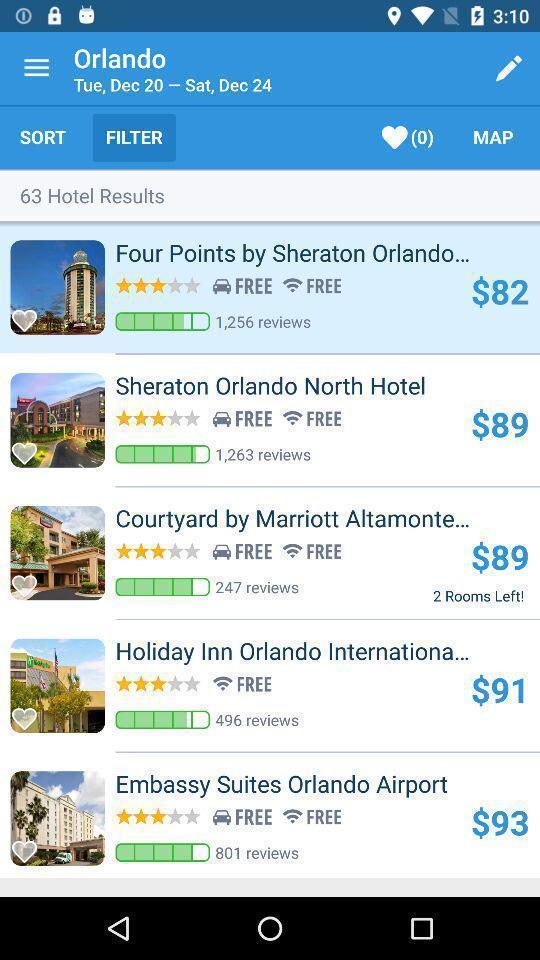Provide a detailed account of this screenshot. Search results of hotels in a location in travel app. 